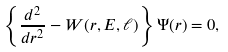Convert formula to latex. <formula><loc_0><loc_0><loc_500><loc_500>\left \{ \frac { d ^ { 2 } } { d r ^ { 2 } } - W ( r , E , \ell ) \right \} \Psi ( r ) = 0 ,</formula> 